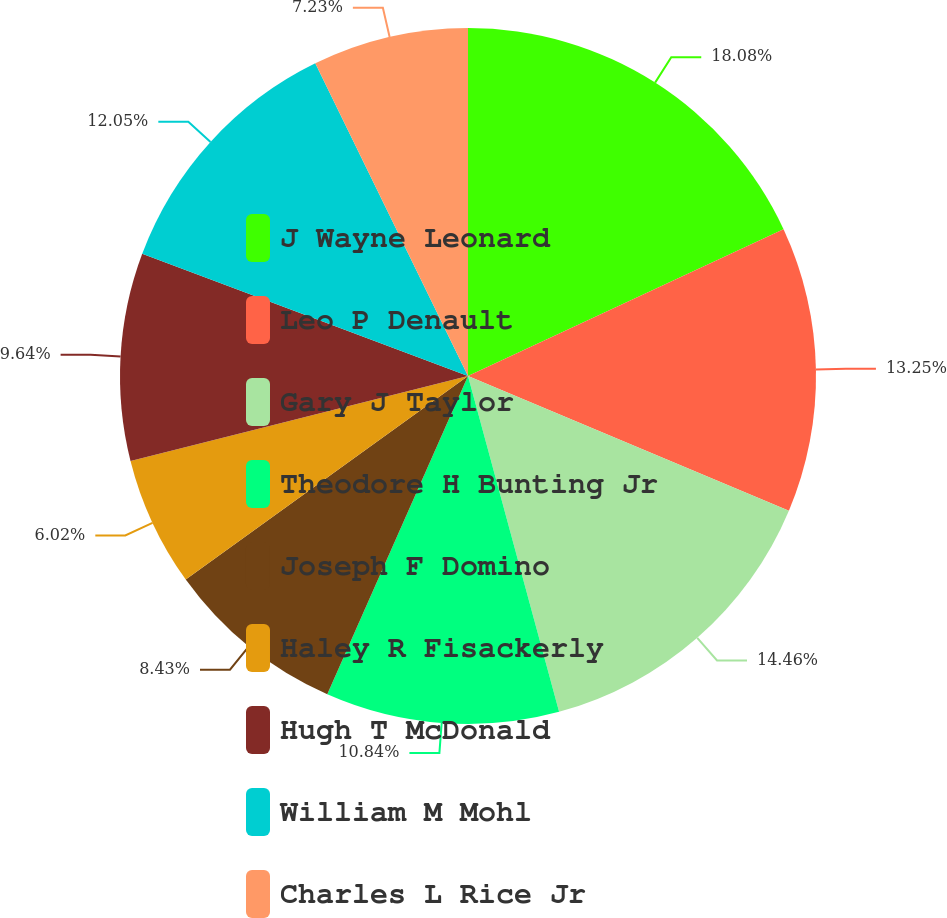Convert chart to OTSL. <chart><loc_0><loc_0><loc_500><loc_500><pie_chart><fcel>J Wayne Leonard<fcel>Leo P Denault<fcel>Gary J Taylor<fcel>Theodore H Bunting Jr<fcel>Joseph F Domino<fcel>Haley R Fisackerly<fcel>Hugh T McDonald<fcel>William M Mohl<fcel>Charles L Rice Jr<nl><fcel>18.07%<fcel>13.25%<fcel>14.46%<fcel>10.84%<fcel>8.43%<fcel>6.02%<fcel>9.64%<fcel>12.05%<fcel>7.23%<nl></chart> 